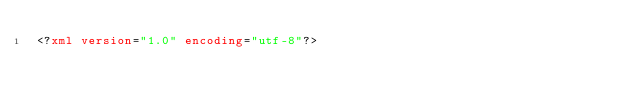Convert code to text. <code><loc_0><loc_0><loc_500><loc_500><_XML_><?xml version="1.0" encoding="utf-8"?></code> 